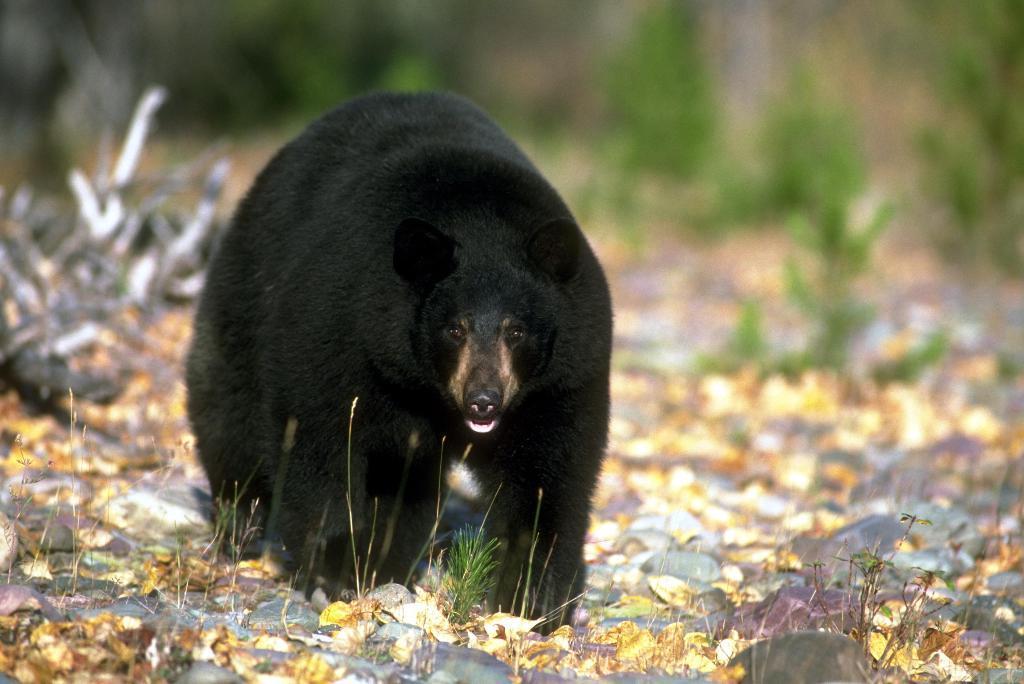Please provide a concise description of this image. In the picture we can see a surface with dried leaves, grass particles and a bear standing on it which is black in color and behind we can see some plants which are not clearly visible. 